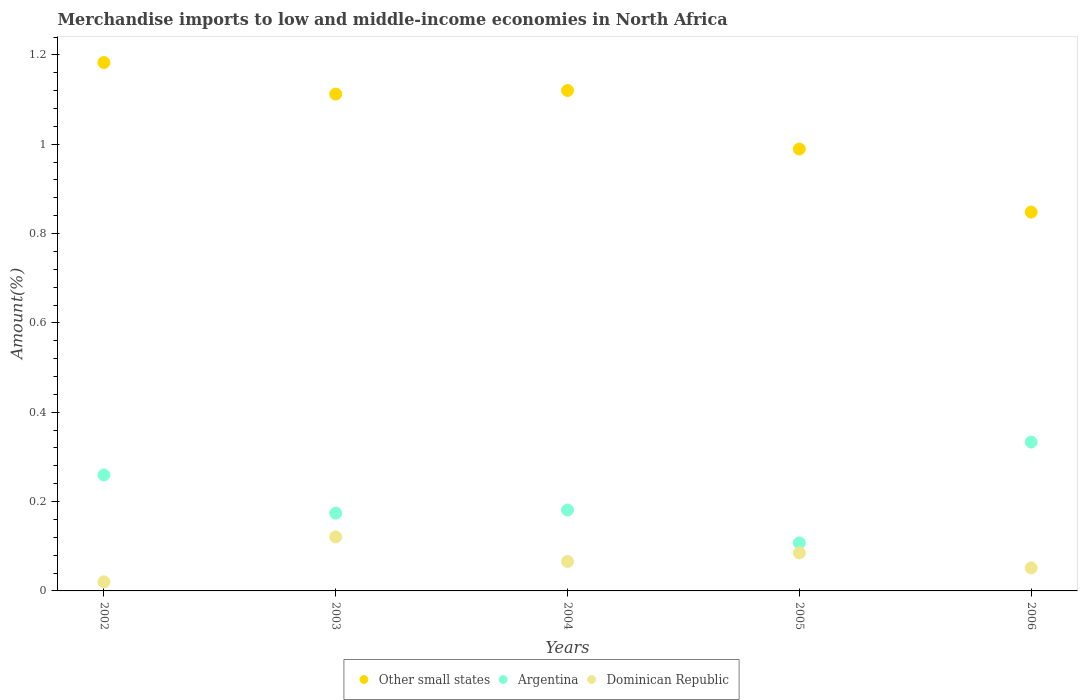How many different coloured dotlines are there?
Your answer should be very brief. 3. Is the number of dotlines equal to the number of legend labels?
Your answer should be compact. Yes. What is the percentage of amount earned from merchandise imports in Dominican Republic in 2002?
Offer a very short reply. 0.02. Across all years, what is the maximum percentage of amount earned from merchandise imports in Dominican Republic?
Provide a succinct answer. 0.12. Across all years, what is the minimum percentage of amount earned from merchandise imports in Other small states?
Your answer should be very brief. 0.85. What is the total percentage of amount earned from merchandise imports in Dominican Republic in the graph?
Keep it short and to the point. 0.34. What is the difference between the percentage of amount earned from merchandise imports in Dominican Republic in 2003 and that in 2006?
Offer a very short reply. 0.07. What is the difference between the percentage of amount earned from merchandise imports in Dominican Republic in 2002 and the percentage of amount earned from merchandise imports in Argentina in 2005?
Make the answer very short. -0.09. What is the average percentage of amount earned from merchandise imports in Other small states per year?
Give a very brief answer. 1.05. In the year 2005, what is the difference between the percentage of amount earned from merchandise imports in Argentina and percentage of amount earned from merchandise imports in Other small states?
Your answer should be very brief. -0.88. What is the ratio of the percentage of amount earned from merchandise imports in Argentina in 2002 to that in 2004?
Make the answer very short. 1.43. Is the percentage of amount earned from merchandise imports in Dominican Republic in 2005 less than that in 2006?
Keep it short and to the point. No. Is the difference between the percentage of amount earned from merchandise imports in Argentina in 2003 and 2005 greater than the difference between the percentage of amount earned from merchandise imports in Other small states in 2003 and 2005?
Provide a short and direct response. No. What is the difference between the highest and the second highest percentage of amount earned from merchandise imports in Other small states?
Your response must be concise. 0.06. What is the difference between the highest and the lowest percentage of amount earned from merchandise imports in Argentina?
Your response must be concise. 0.23. Is the sum of the percentage of amount earned from merchandise imports in Other small states in 2002 and 2003 greater than the maximum percentage of amount earned from merchandise imports in Dominican Republic across all years?
Provide a succinct answer. Yes. Is it the case that in every year, the sum of the percentage of amount earned from merchandise imports in Dominican Republic and percentage of amount earned from merchandise imports in Argentina  is greater than the percentage of amount earned from merchandise imports in Other small states?
Ensure brevity in your answer.  No. Is the percentage of amount earned from merchandise imports in Argentina strictly greater than the percentage of amount earned from merchandise imports in Dominican Republic over the years?
Offer a terse response. Yes. How many years are there in the graph?
Your response must be concise. 5. What is the difference between two consecutive major ticks on the Y-axis?
Give a very brief answer. 0.2. Does the graph contain grids?
Your answer should be very brief. No. How many legend labels are there?
Offer a very short reply. 3. How are the legend labels stacked?
Offer a terse response. Horizontal. What is the title of the graph?
Offer a terse response. Merchandise imports to low and middle-income economies in North Africa. What is the label or title of the Y-axis?
Your answer should be very brief. Amount(%). What is the Amount(%) in Other small states in 2002?
Your response must be concise. 1.18. What is the Amount(%) of Argentina in 2002?
Provide a succinct answer. 0.26. What is the Amount(%) of Dominican Republic in 2002?
Keep it short and to the point. 0.02. What is the Amount(%) of Other small states in 2003?
Keep it short and to the point. 1.11. What is the Amount(%) in Argentina in 2003?
Your answer should be very brief. 0.17. What is the Amount(%) in Dominican Republic in 2003?
Give a very brief answer. 0.12. What is the Amount(%) in Other small states in 2004?
Provide a succinct answer. 1.12. What is the Amount(%) of Argentina in 2004?
Make the answer very short. 0.18. What is the Amount(%) in Dominican Republic in 2004?
Ensure brevity in your answer.  0.07. What is the Amount(%) in Other small states in 2005?
Keep it short and to the point. 0.99. What is the Amount(%) in Argentina in 2005?
Your answer should be compact. 0.11. What is the Amount(%) of Dominican Republic in 2005?
Offer a very short reply. 0.09. What is the Amount(%) of Other small states in 2006?
Give a very brief answer. 0.85. What is the Amount(%) of Argentina in 2006?
Keep it short and to the point. 0.33. What is the Amount(%) in Dominican Republic in 2006?
Your answer should be compact. 0.05. Across all years, what is the maximum Amount(%) of Other small states?
Offer a terse response. 1.18. Across all years, what is the maximum Amount(%) in Argentina?
Your answer should be very brief. 0.33. Across all years, what is the maximum Amount(%) of Dominican Republic?
Keep it short and to the point. 0.12. Across all years, what is the minimum Amount(%) in Other small states?
Your answer should be very brief. 0.85. Across all years, what is the minimum Amount(%) of Argentina?
Give a very brief answer. 0.11. Across all years, what is the minimum Amount(%) in Dominican Republic?
Offer a terse response. 0.02. What is the total Amount(%) of Other small states in the graph?
Keep it short and to the point. 5.25. What is the total Amount(%) in Argentina in the graph?
Provide a succinct answer. 1.06. What is the total Amount(%) in Dominican Republic in the graph?
Provide a short and direct response. 0.34. What is the difference between the Amount(%) of Other small states in 2002 and that in 2003?
Your answer should be compact. 0.07. What is the difference between the Amount(%) in Argentina in 2002 and that in 2003?
Make the answer very short. 0.09. What is the difference between the Amount(%) in Dominican Republic in 2002 and that in 2003?
Offer a terse response. -0.1. What is the difference between the Amount(%) in Other small states in 2002 and that in 2004?
Provide a short and direct response. 0.06. What is the difference between the Amount(%) of Argentina in 2002 and that in 2004?
Give a very brief answer. 0.08. What is the difference between the Amount(%) of Dominican Republic in 2002 and that in 2004?
Your answer should be very brief. -0.05. What is the difference between the Amount(%) in Other small states in 2002 and that in 2005?
Provide a succinct answer. 0.19. What is the difference between the Amount(%) in Argentina in 2002 and that in 2005?
Make the answer very short. 0.15. What is the difference between the Amount(%) in Dominican Republic in 2002 and that in 2005?
Provide a short and direct response. -0.06. What is the difference between the Amount(%) in Other small states in 2002 and that in 2006?
Give a very brief answer. 0.33. What is the difference between the Amount(%) of Argentina in 2002 and that in 2006?
Offer a terse response. -0.07. What is the difference between the Amount(%) of Dominican Republic in 2002 and that in 2006?
Offer a very short reply. -0.03. What is the difference between the Amount(%) of Other small states in 2003 and that in 2004?
Ensure brevity in your answer.  -0.01. What is the difference between the Amount(%) in Argentina in 2003 and that in 2004?
Ensure brevity in your answer.  -0.01. What is the difference between the Amount(%) of Dominican Republic in 2003 and that in 2004?
Your answer should be very brief. 0.05. What is the difference between the Amount(%) in Other small states in 2003 and that in 2005?
Your answer should be very brief. 0.12. What is the difference between the Amount(%) of Argentina in 2003 and that in 2005?
Make the answer very short. 0.07. What is the difference between the Amount(%) in Dominican Republic in 2003 and that in 2005?
Offer a terse response. 0.04. What is the difference between the Amount(%) in Other small states in 2003 and that in 2006?
Make the answer very short. 0.26. What is the difference between the Amount(%) of Argentina in 2003 and that in 2006?
Your response must be concise. -0.16. What is the difference between the Amount(%) in Dominican Republic in 2003 and that in 2006?
Provide a succinct answer. 0.07. What is the difference between the Amount(%) of Other small states in 2004 and that in 2005?
Your response must be concise. 0.13. What is the difference between the Amount(%) of Argentina in 2004 and that in 2005?
Give a very brief answer. 0.07. What is the difference between the Amount(%) of Dominican Republic in 2004 and that in 2005?
Give a very brief answer. -0.02. What is the difference between the Amount(%) of Other small states in 2004 and that in 2006?
Offer a terse response. 0.27. What is the difference between the Amount(%) of Argentina in 2004 and that in 2006?
Provide a short and direct response. -0.15. What is the difference between the Amount(%) of Dominican Republic in 2004 and that in 2006?
Provide a succinct answer. 0.01. What is the difference between the Amount(%) in Other small states in 2005 and that in 2006?
Your answer should be compact. 0.14. What is the difference between the Amount(%) of Argentina in 2005 and that in 2006?
Keep it short and to the point. -0.23. What is the difference between the Amount(%) of Dominican Republic in 2005 and that in 2006?
Give a very brief answer. 0.03. What is the difference between the Amount(%) in Other small states in 2002 and the Amount(%) in Argentina in 2003?
Offer a very short reply. 1.01. What is the difference between the Amount(%) in Other small states in 2002 and the Amount(%) in Dominican Republic in 2003?
Ensure brevity in your answer.  1.06. What is the difference between the Amount(%) in Argentina in 2002 and the Amount(%) in Dominican Republic in 2003?
Provide a succinct answer. 0.14. What is the difference between the Amount(%) in Other small states in 2002 and the Amount(%) in Dominican Republic in 2004?
Provide a short and direct response. 1.12. What is the difference between the Amount(%) of Argentina in 2002 and the Amount(%) of Dominican Republic in 2004?
Keep it short and to the point. 0.19. What is the difference between the Amount(%) in Other small states in 2002 and the Amount(%) in Argentina in 2005?
Your answer should be compact. 1.08. What is the difference between the Amount(%) of Other small states in 2002 and the Amount(%) of Dominican Republic in 2005?
Your answer should be very brief. 1.1. What is the difference between the Amount(%) in Argentina in 2002 and the Amount(%) in Dominican Republic in 2005?
Your answer should be very brief. 0.17. What is the difference between the Amount(%) in Other small states in 2002 and the Amount(%) in Argentina in 2006?
Ensure brevity in your answer.  0.85. What is the difference between the Amount(%) in Other small states in 2002 and the Amount(%) in Dominican Republic in 2006?
Make the answer very short. 1.13. What is the difference between the Amount(%) of Argentina in 2002 and the Amount(%) of Dominican Republic in 2006?
Your answer should be very brief. 0.21. What is the difference between the Amount(%) of Other small states in 2003 and the Amount(%) of Argentina in 2004?
Give a very brief answer. 0.93. What is the difference between the Amount(%) in Other small states in 2003 and the Amount(%) in Dominican Republic in 2004?
Provide a short and direct response. 1.05. What is the difference between the Amount(%) in Argentina in 2003 and the Amount(%) in Dominican Republic in 2004?
Give a very brief answer. 0.11. What is the difference between the Amount(%) of Other small states in 2003 and the Amount(%) of Argentina in 2005?
Give a very brief answer. 1. What is the difference between the Amount(%) of Other small states in 2003 and the Amount(%) of Dominican Republic in 2005?
Ensure brevity in your answer.  1.03. What is the difference between the Amount(%) in Argentina in 2003 and the Amount(%) in Dominican Republic in 2005?
Give a very brief answer. 0.09. What is the difference between the Amount(%) in Other small states in 2003 and the Amount(%) in Argentina in 2006?
Your response must be concise. 0.78. What is the difference between the Amount(%) in Other small states in 2003 and the Amount(%) in Dominican Republic in 2006?
Provide a succinct answer. 1.06. What is the difference between the Amount(%) in Argentina in 2003 and the Amount(%) in Dominican Republic in 2006?
Give a very brief answer. 0.12. What is the difference between the Amount(%) of Other small states in 2004 and the Amount(%) of Argentina in 2005?
Offer a very short reply. 1.01. What is the difference between the Amount(%) of Other small states in 2004 and the Amount(%) of Dominican Republic in 2005?
Provide a succinct answer. 1.04. What is the difference between the Amount(%) in Argentina in 2004 and the Amount(%) in Dominican Republic in 2005?
Your response must be concise. 0.1. What is the difference between the Amount(%) in Other small states in 2004 and the Amount(%) in Argentina in 2006?
Ensure brevity in your answer.  0.79. What is the difference between the Amount(%) of Other small states in 2004 and the Amount(%) of Dominican Republic in 2006?
Provide a short and direct response. 1.07. What is the difference between the Amount(%) in Argentina in 2004 and the Amount(%) in Dominican Republic in 2006?
Offer a very short reply. 0.13. What is the difference between the Amount(%) in Other small states in 2005 and the Amount(%) in Argentina in 2006?
Make the answer very short. 0.66. What is the difference between the Amount(%) in Other small states in 2005 and the Amount(%) in Dominican Republic in 2006?
Ensure brevity in your answer.  0.94. What is the difference between the Amount(%) of Argentina in 2005 and the Amount(%) of Dominican Republic in 2006?
Your response must be concise. 0.06. What is the average Amount(%) in Other small states per year?
Offer a very short reply. 1.05. What is the average Amount(%) in Argentina per year?
Give a very brief answer. 0.21. What is the average Amount(%) in Dominican Republic per year?
Make the answer very short. 0.07. In the year 2002, what is the difference between the Amount(%) of Other small states and Amount(%) of Argentina?
Ensure brevity in your answer.  0.92. In the year 2002, what is the difference between the Amount(%) of Other small states and Amount(%) of Dominican Republic?
Provide a succinct answer. 1.16. In the year 2002, what is the difference between the Amount(%) of Argentina and Amount(%) of Dominican Republic?
Provide a succinct answer. 0.24. In the year 2003, what is the difference between the Amount(%) of Other small states and Amount(%) of Argentina?
Provide a short and direct response. 0.94. In the year 2003, what is the difference between the Amount(%) in Argentina and Amount(%) in Dominican Republic?
Ensure brevity in your answer.  0.05. In the year 2004, what is the difference between the Amount(%) in Other small states and Amount(%) in Argentina?
Give a very brief answer. 0.94. In the year 2004, what is the difference between the Amount(%) in Other small states and Amount(%) in Dominican Republic?
Ensure brevity in your answer.  1.05. In the year 2004, what is the difference between the Amount(%) of Argentina and Amount(%) of Dominican Republic?
Provide a succinct answer. 0.12. In the year 2005, what is the difference between the Amount(%) in Other small states and Amount(%) in Argentina?
Your response must be concise. 0.88. In the year 2005, what is the difference between the Amount(%) of Other small states and Amount(%) of Dominican Republic?
Provide a short and direct response. 0.9. In the year 2005, what is the difference between the Amount(%) in Argentina and Amount(%) in Dominican Republic?
Provide a succinct answer. 0.02. In the year 2006, what is the difference between the Amount(%) in Other small states and Amount(%) in Argentina?
Your answer should be compact. 0.51. In the year 2006, what is the difference between the Amount(%) in Other small states and Amount(%) in Dominican Republic?
Your answer should be very brief. 0.8. In the year 2006, what is the difference between the Amount(%) of Argentina and Amount(%) of Dominican Republic?
Make the answer very short. 0.28. What is the ratio of the Amount(%) of Other small states in 2002 to that in 2003?
Provide a succinct answer. 1.06. What is the ratio of the Amount(%) of Argentina in 2002 to that in 2003?
Provide a short and direct response. 1.49. What is the ratio of the Amount(%) in Dominican Republic in 2002 to that in 2003?
Ensure brevity in your answer.  0.17. What is the ratio of the Amount(%) of Other small states in 2002 to that in 2004?
Offer a terse response. 1.06. What is the ratio of the Amount(%) of Argentina in 2002 to that in 2004?
Give a very brief answer. 1.43. What is the ratio of the Amount(%) in Dominican Republic in 2002 to that in 2004?
Offer a very short reply. 0.31. What is the ratio of the Amount(%) in Other small states in 2002 to that in 2005?
Give a very brief answer. 1.2. What is the ratio of the Amount(%) of Argentina in 2002 to that in 2005?
Provide a succinct answer. 2.42. What is the ratio of the Amount(%) of Dominican Republic in 2002 to that in 2005?
Your answer should be compact. 0.24. What is the ratio of the Amount(%) of Other small states in 2002 to that in 2006?
Keep it short and to the point. 1.39. What is the ratio of the Amount(%) in Argentina in 2002 to that in 2006?
Offer a very short reply. 0.78. What is the ratio of the Amount(%) in Dominican Republic in 2002 to that in 2006?
Make the answer very short. 0.39. What is the ratio of the Amount(%) in Argentina in 2003 to that in 2004?
Your response must be concise. 0.96. What is the ratio of the Amount(%) of Dominican Republic in 2003 to that in 2004?
Your answer should be very brief. 1.83. What is the ratio of the Amount(%) of Other small states in 2003 to that in 2005?
Provide a short and direct response. 1.12. What is the ratio of the Amount(%) in Argentina in 2003 to that in 2005?
Ensure brevity in your answer.  1.62. What is the ratio of the Amount(%) in Dominican Republic in 2003 to that in 2005?
Ensure brevity in your answer.  1.42. What is the ratio of the Amount(%) in Other small states in 2003 to that in 2006?
Your answer should be very brief. 1.31. What is the ratio of the Amount(%) in Argentina in 2003 to that in 2006?
Offer a very short reply. 0.52. What is the ratio of the Amount(%) of Dominican Republic in 2003 to that in 2006?
Ensure brevity in your answer.  2.35. What is the ratio of the Amount(%) in Other small states in 2004 to that in 2005?
Your answer should be compact. 1.13. What is the ratio of the Amount(%) in Argentina in 2004 to that in 2005?
Ensure brevity in your answer.  1.69. What is the ratio of the Amount(%) in Dominican Republic in 2004 to that in 2005?
Make the answer very short. 0.77. What is the ratio of the Amount(%) in Other small states in 2004 to that in 2006?
Provide a succinct answer. 1.32. What is the ratio of the Amount(%) of Argentina in 2004 to that in 2006?
Give a very brief answer. 0.54. What is the ratio of the Amount(%) of Dominican Republic in 2004 to that in 2006?
Ensure brevity in your answer.  1.28. What is the ratio of the Amount(%) of Other small states in 2005 to that in 2006?
Give a very brief answer. 1.17. What is the ratio of the Amount(%) of Argentina in 2005 to that in 2006?
Make the answer very short. 0.32. What is the ratio of the Amount(%) in Dominican Republic in 2005 to that in 2006?
Provide a short and direct response. 1.65. What is the difference between the highest and the second highest Amount(%) of Other small states?
Your response must be concise. 0.06. What is the difference between the highest and the second highest Amount(%) of Argentina?
Provide a succinct answer. 0.07. What is the difference between the highest and the second highest Amount(%) in Dominican Republic?
Your answer should be very brief. 0.04. What is the difference between the highest and the lowest Amount(%) in Other small states?
Your response must be concise. 0.33. What is the difference between the highest and the lowest Amount(%) in Argentina?
Give a very brief answer. 0.23. What is the difference between the highest and the lowest Amount(%) of Dominican Republic?
Your response must be concise. 0.1. 